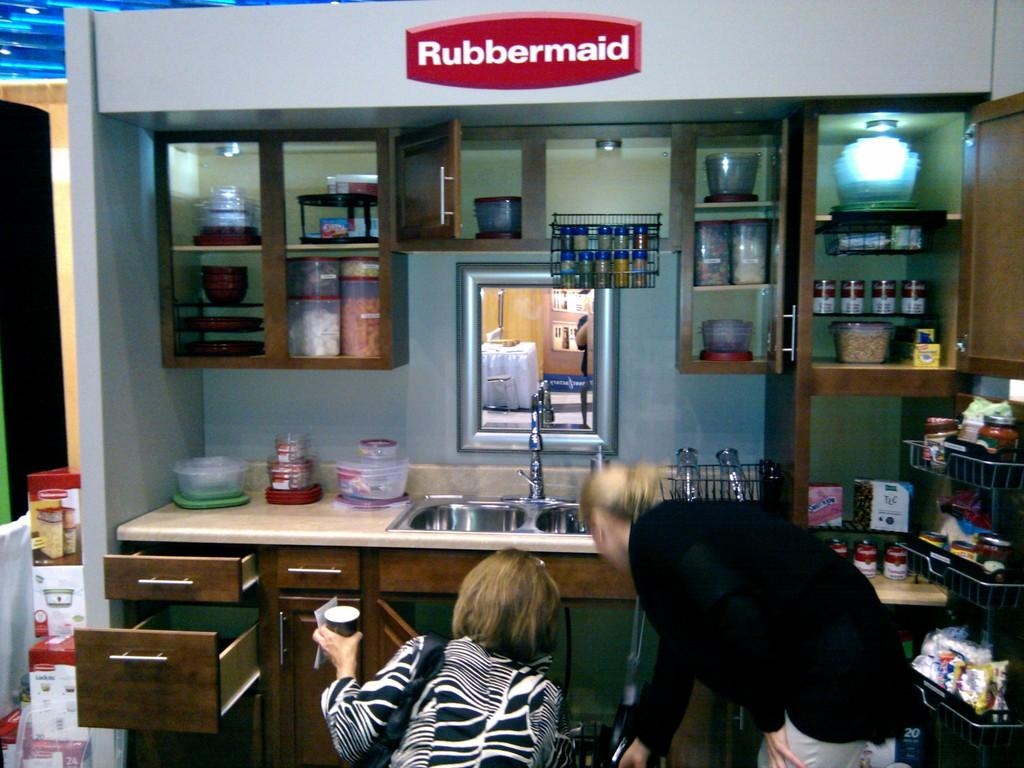<image>
Summarize the visual content of the image. Two women are looking under a kitchen sink with a Rubbermaid sign on the wall. 